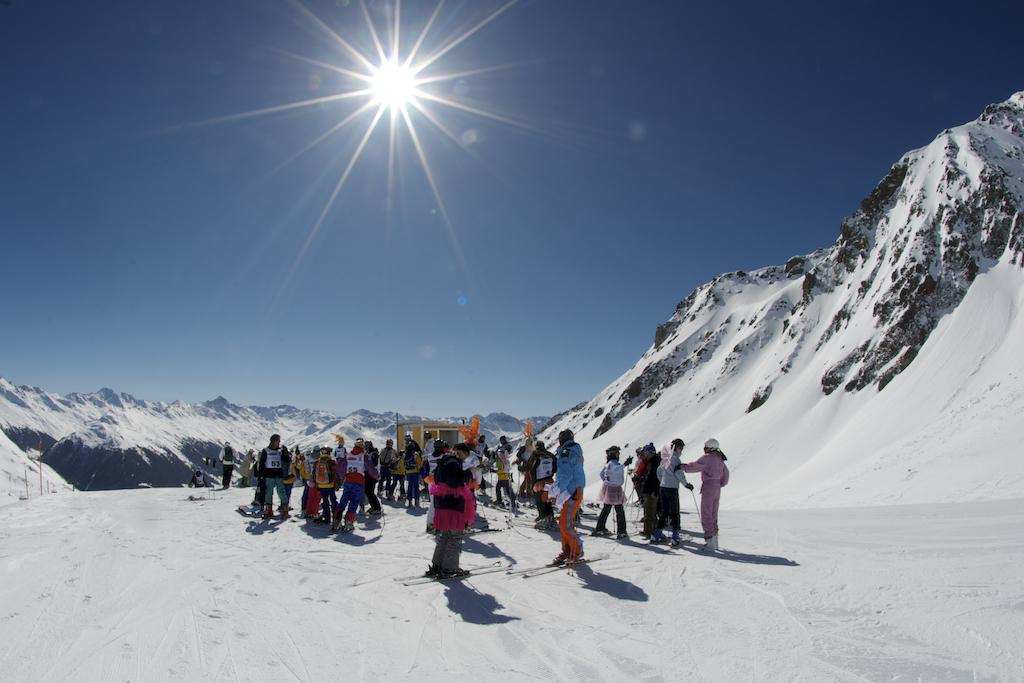Who or what can be seen in the image? There are people in the image. What type of surface is visible in the image? There is ground visible in the image. What is present on the ground? There are objects on the ground. What type of natural feature can be seen in the image? There are hills in the image. What is visible in the sky? The sky is visible in the image, and the sun is visible in the sky. What additional elements are present in the image? There are flags in the image. What type of salt can be seen on the back of the people in the image? There is no salt visible in the image, and the people's backs are not mentioned in the facts provided. 